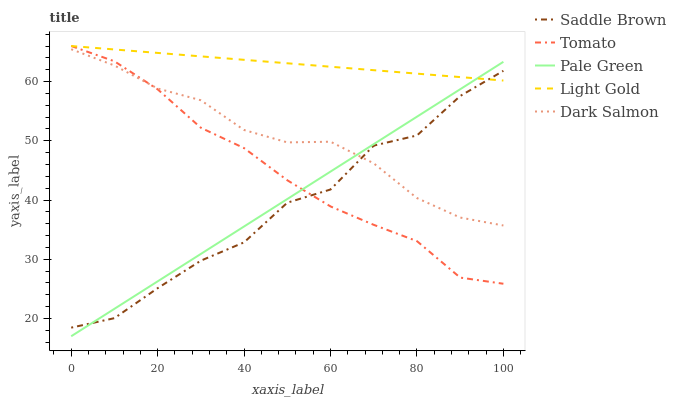Does Saddle Brown have the minimum area under the curve?
Answer yes or no. Yes. Does Light Gold have the maximum area under the curve?
Answer yes or no. Yes. Does Pale Green have the minimum area under the curve?
Answer yes or no. No. Does Pale Green have the maximum area under the curve?
Answer yes or no. No. Is Pale Green the smoothest?
Answer yes or no. Yes. Is Saddle Brown the roughest?
Answer yes or no. Yes. Is Light Gold the smoothest?
Answer yes or no. No. Is Light Gold the roughest?
Answer yes or no. No. Does Pale Green have the lowest value?
Answer yes or no. Yes. Does Light Gold have the lowest value?
Answer yes or no. No. Does Light Gold have the highest value?
Answer yes or no. Yes. Does Pale Green have the highest value?
Answer yes or no. No. Is Dark Salmon less than Light Gold?
Answer yes or no. Yes. Is Light Gold greater than Dark Salmon?
Answer yes or no. Yes. Does Pale Green intersect Tomato?
Answer yes or no. Yes. Is Pale Green less than Tomato?
Answer yes or no. No. Is Pale Green greater than Tomato?
Answer yes or no. No. Does Dark Salmon intersect Light Gold?
Answer yes or no. No. 